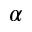<formula> <loc_0><loc_0><loc_500><loc_500>\alpha</formula> 